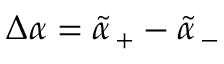<formula> <loc_0><loc_0><loc_500><loc_500>\Delta \alpha = \tilde { \alpha } _ { \, + } - \tilde { \alpha } _ { \, - }</formula> 